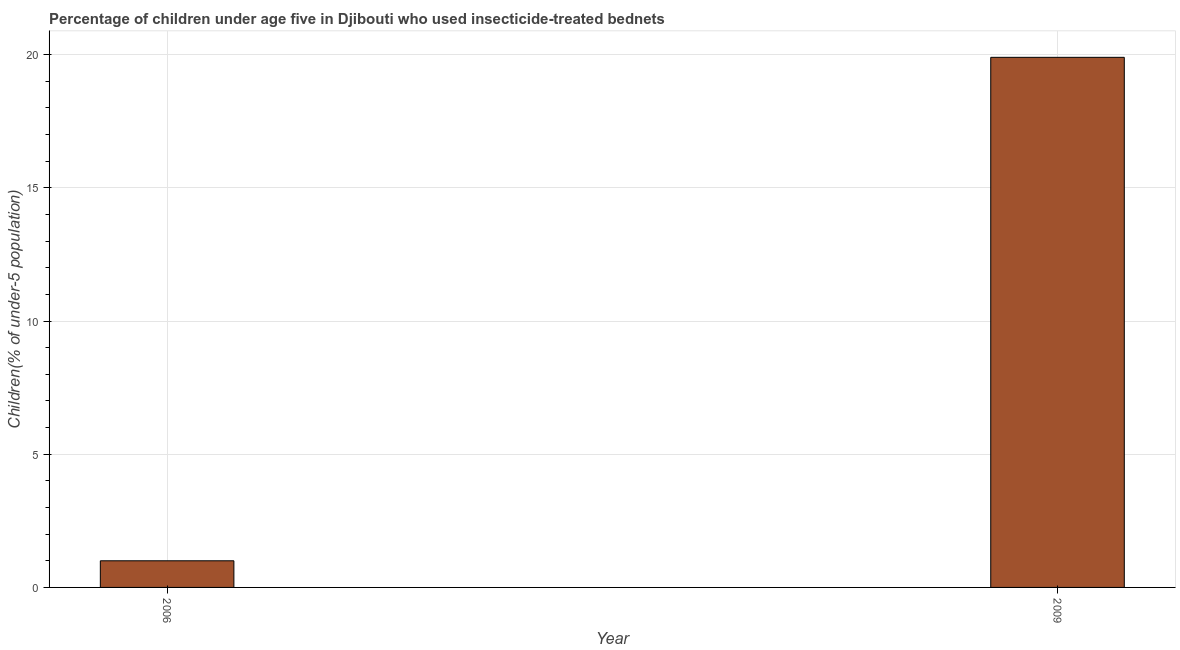Does the graph contain any zero values?
Give a very brief answer. No. Does the graph contain grids?
Keep it short and to the point. Yes. What is the title of the graph?
Your answer should be very brief. Percentage of children under age five in Djibouti who used insecticide-treated bednets. What is the label or title of the Y-axis?
Make the answer very short. Children(% of under-5 population). In which year was the percentage of children who use of insecticide-treated bed nets maximum?
Keep it short and to the point. 2009. What is the sum of the percentage of children who use of insecticide-treated bed nets?
Provide a succinct answer. 20.9. What is the difference between the percentage of children who use of insecticide-treated bed nets in 2006 and 2009?
Keep it short and to the point. -18.9. What is the average percentage of children who use of insecticide-treated bed nets per year?
Give a very brief answer. 10.45. What is the median percentage of children who use of insecticide-treated bed nets?
Provide a short and direct response. 10.45. In how many years, is the percentage of children who use of insecticide-treated bed nets greater than 17 %?
Provide a succinct answer. 1. What is the ratio of the percentage of children who use of insecticide-treated bed nets in 2006 to that in 2009?
Offer a terse response. 0.05. How many bars are there?
Keep it short and to the point. 2. What is the difference between two consecutive major ticks on the Y-axis?
Ensure brevity in your answer.  5. What is the Children(% of under-5 population) in 2009?
Ensure brevity in your answer.  19.9. What is the difference between the Children(% of under-5 population) in 2006 and 2009?
Your response must be concise. -18.9. What is the ratio of the Children(% of under-5 population) in 2006 to that in 2009?
Your answer should be very brief. 0.05. 